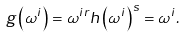<formula> <loc_0><loc_0><loc_500><loc_500>g \left ( \omega ^ { i } \right ) = \omega ^ { i r } h \left ( \omega ^ { i } \right ) ^ { s } = \omega ^ { i } .</formula> 